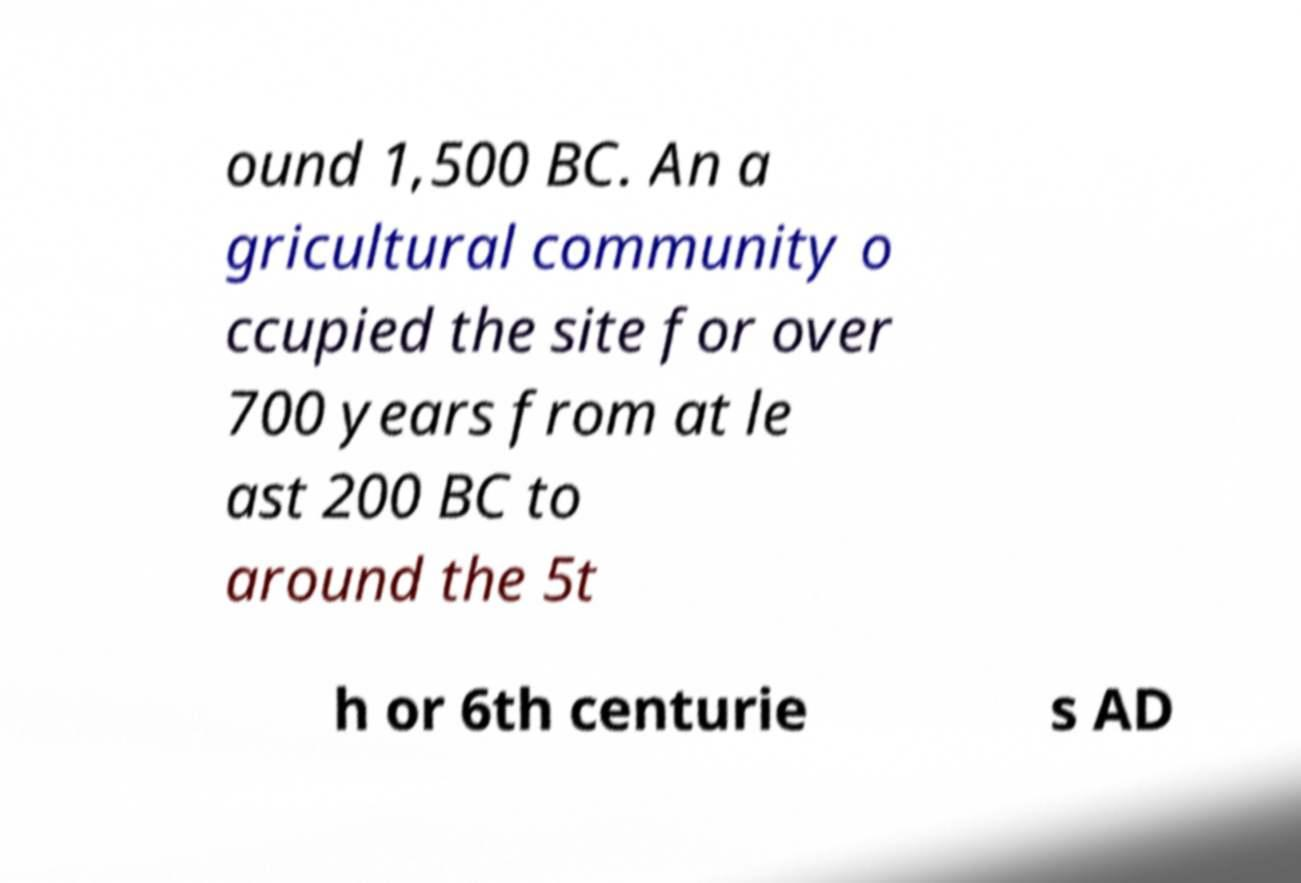Please read and relay the text visible in this image. What does it say? ound 1,500 BC. An a gricultural community o ccupied the site for over 700 years from at le ast 200 BC to around the 5t h or 6th centurie s AD 